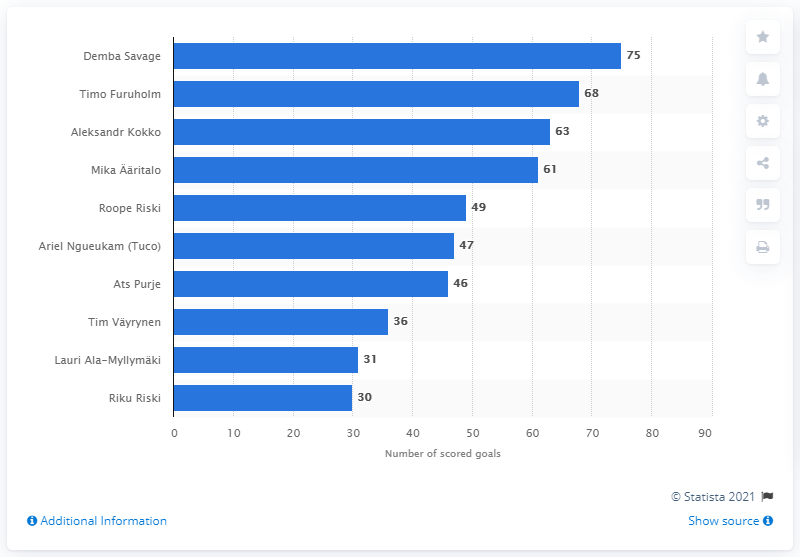Identify some key points in this picture. As of 2020, Demba Savage had 75 goals. With the RoPS striker being Aleksandr Kokko, who is he? 